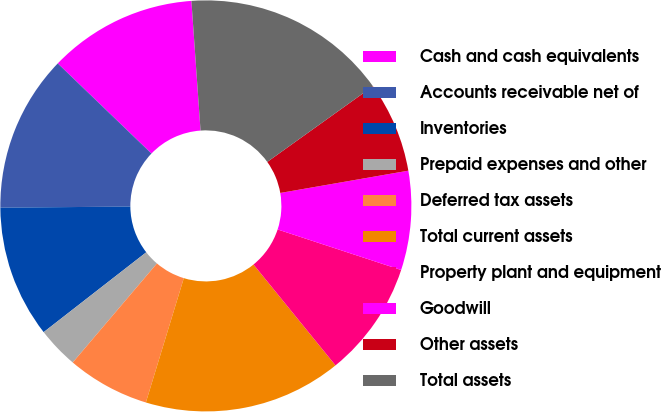<chart> <loc_0><loc_0><loc_500><loc_500><pie_chart><fcel>Cash and cash equivalents<fcel>Accounts receivable net of<fcel>Inventories<fcel>Prepaid expenses and other<fcel>Deferred tax assets<fcel>Total current assets<fcel>Property plant and equipment<fcel>Goodwill<fcel>Other assets<fcel>Total assets<nl><fcel>11.69%<fcel>12.33%<fcel>10.39%<fcel>3.26%<fcel>6.5%<fcel>15.58%<fcel>9.09%<fcel>7.79%<fcel>7.15%<fcel>16.23%<nl></chart> 